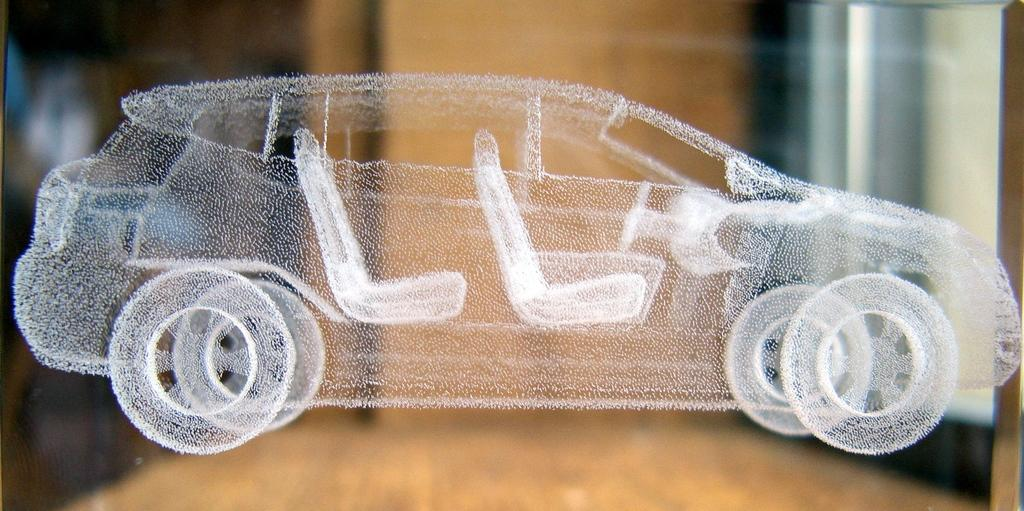What is the main subject of the image? The main subject of the image is an imaginary picture of a car. Where is the car located in the image? The car is depicted over a place. What type of oven can be seen in the image? There is no oven present in the image; it features an imaginary picture of a car. What direction is the car facing in the image? The direction the car is facing cannot be determined from the image, as it is an imaginary picture. 